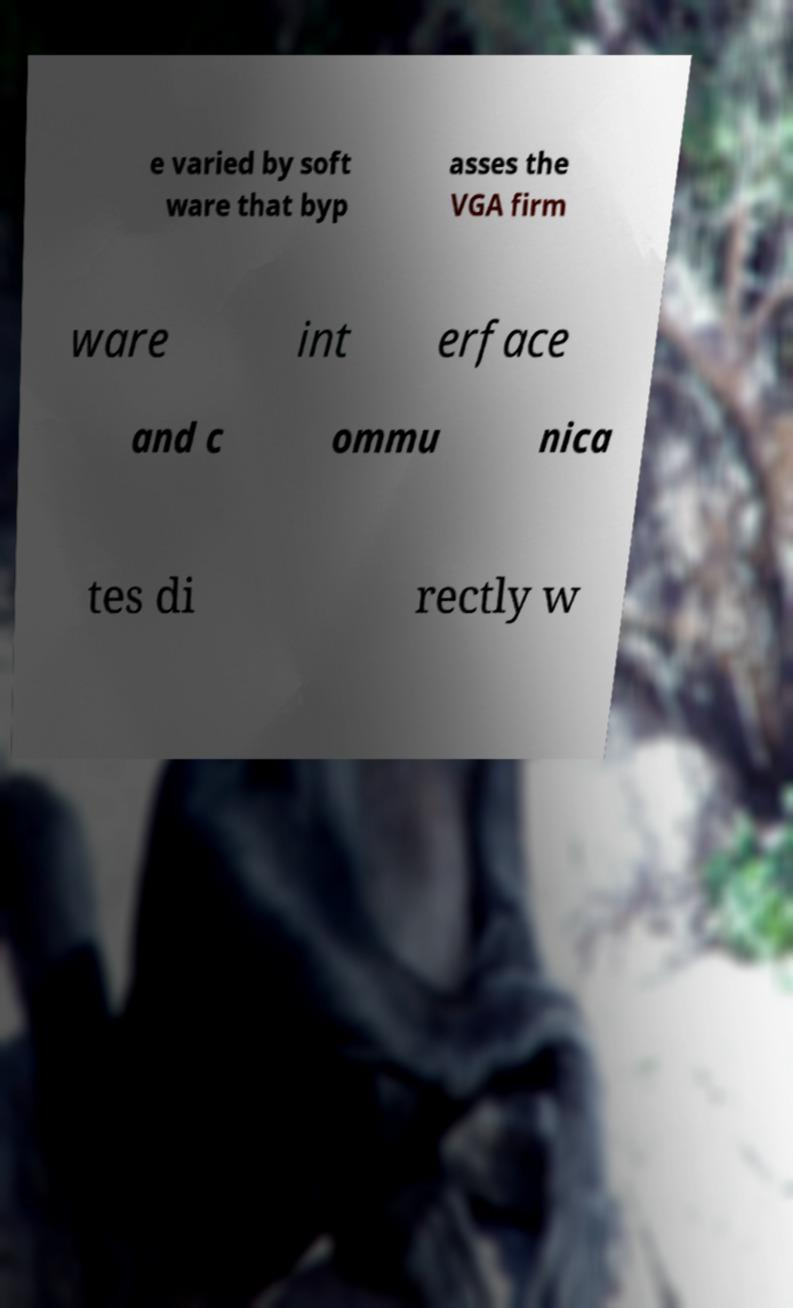For documentation purposes, I need the text within this image transcribed. Could you provide that? e varied by soft ware that byp asses the VGA firm ware int erface and c ommu nica tes di rectly w 